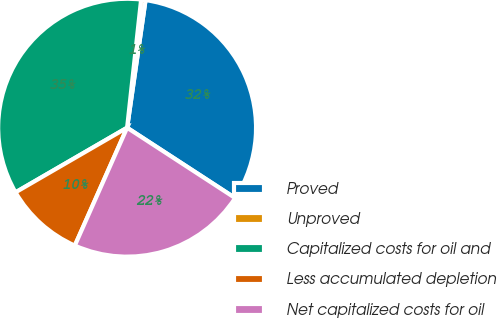<chart> <loc_0><loc_0><loc_500><loc_500><pie_chart><fcel>Proved<fcel>Unproved<fcel>Capitalized costs for oil and<fcel>Less accumulated depletion<fcel>Net capitalized costs for oil<nl><fcel>31.9%<fcel>0.55%<fcel>35.09%<fcel>10.0%<fcel>22.46%<nl></chart> 